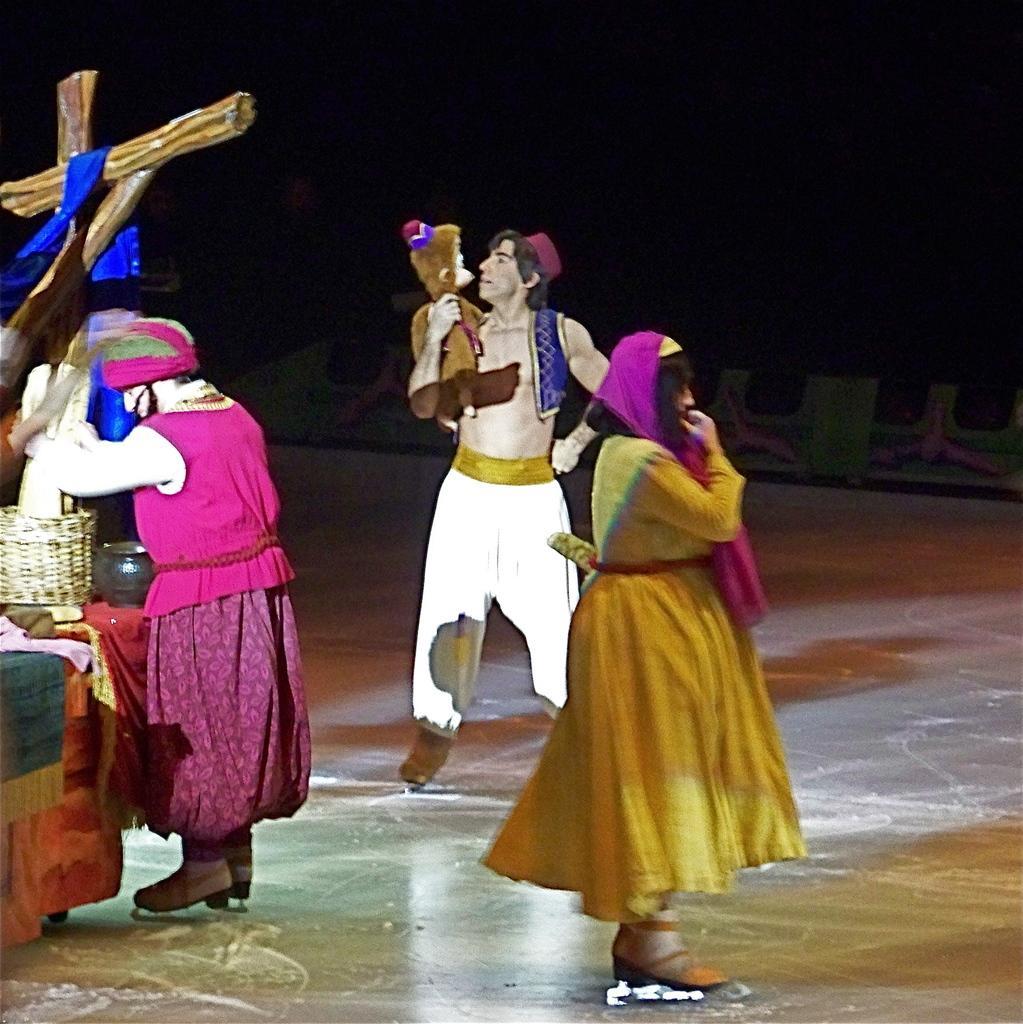Describe this image in one or two sentences. In this image we can see a group of people standing on the floor wearing skates. In the center of the image we can see a person holding a doll. To the left side of the image we can see some wooden poles, and some vessels placed on the table. 